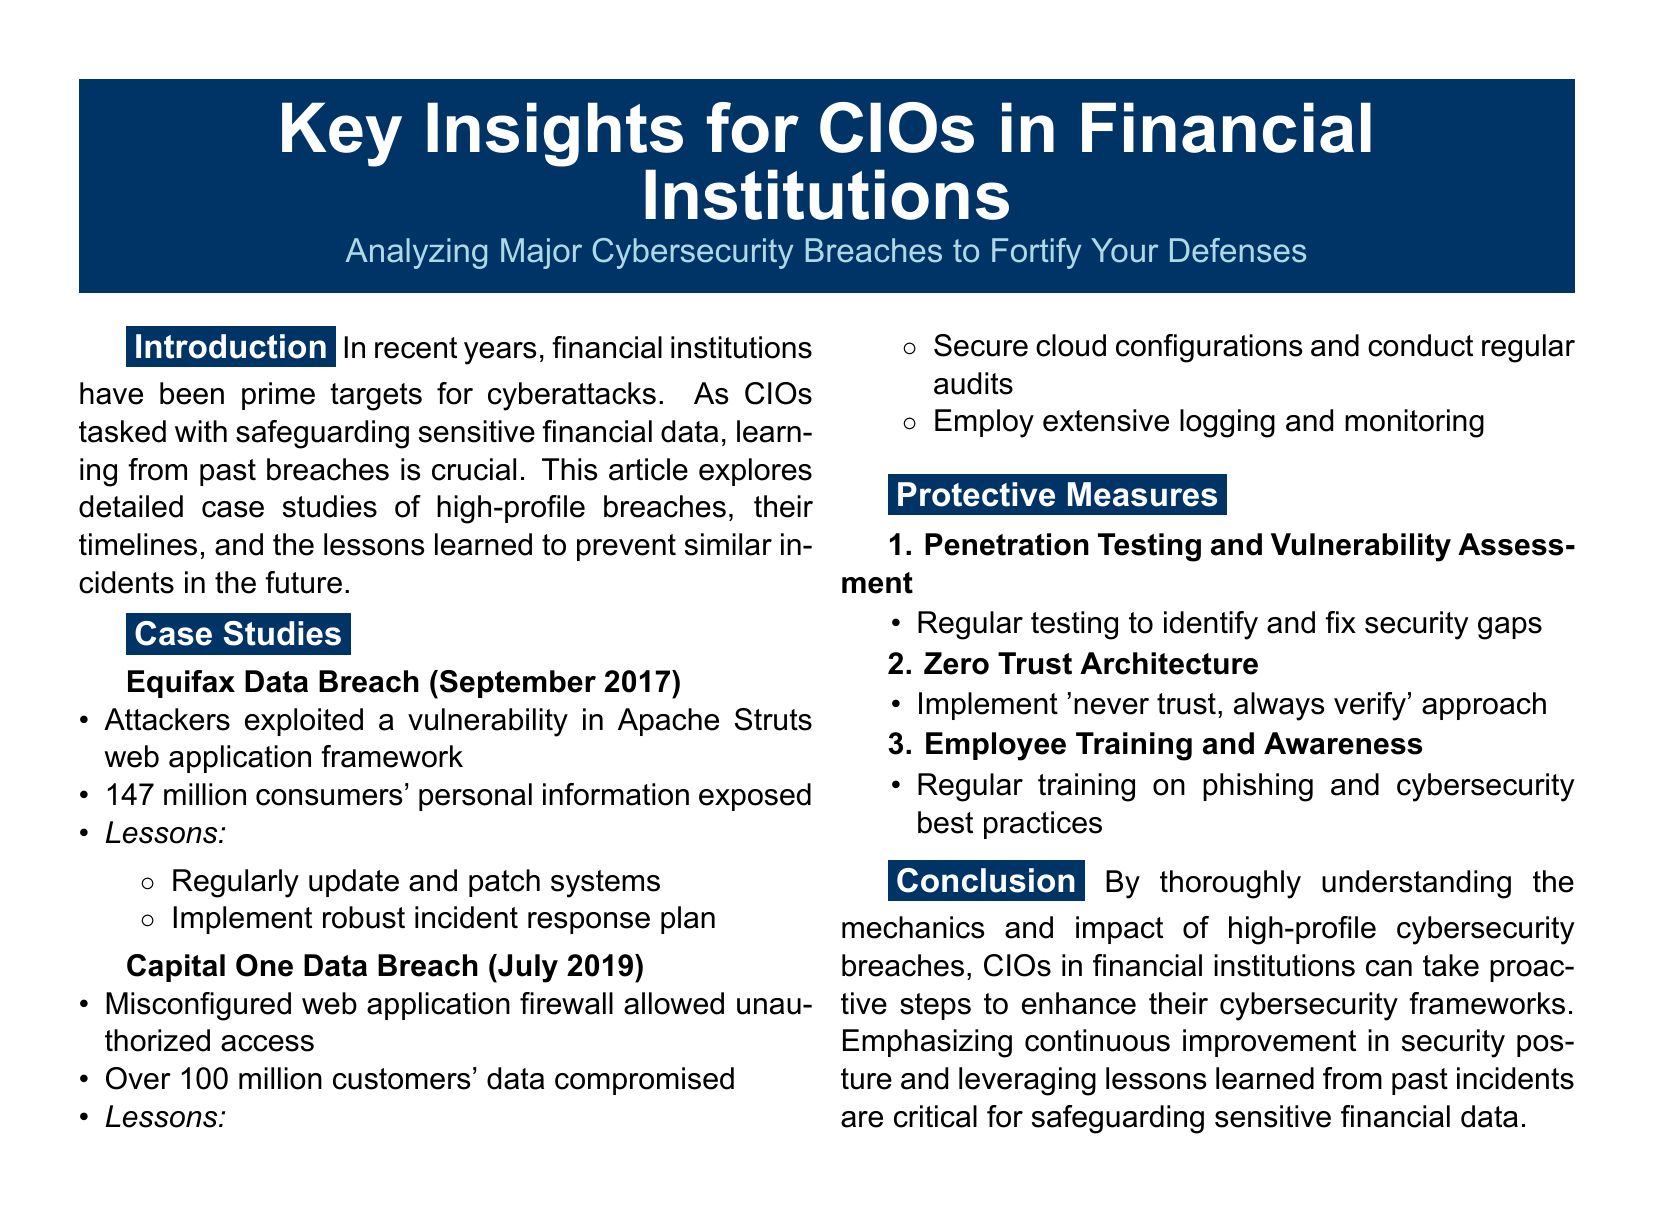What year did the Equifax Data Breach occur? The document states that the Equifax Data Breach occurred in September 2017.
Answer: 2017 How many consumers' personal information was exposed in the Equifax breach? According to the document, 147 million consumers' personal information was exposed in the Equifax breach.
Answer: 147 million What was the cause of the Capital One Data Breach? The document indicates that a misconfigured web application firewall caused the Capital One Data Breach.
Answer: Misconfigured web application firewall What key protective measure is suggested for identifying security gaps? The document lists penetration testing and vulnerability assessment as a key protective measure.
Answer: Penetration testing and vulnerability assessment What breach involved over 100 million customers' data compromised? The document specifies that the Capital One Data Breach involved over 100 million customers' data compromised.
Answer: Capital One Data Breach What is the approach described as 'never trust, always verify'? The document refers to Zero Trust Architecture as the approach described as 'never trust, always verify'.
Answer: Zero Trust Architecture What was a lesson learned from the Equifax breach? The document lists that regularly updating and patching systems was a lesson learned from the Equifax breach.
Answer: Regularly update and patch systems How frequently should training on phishing be conducted according to the document? The document advises regular training on phishing and cybersecurity best practices.
Answer: Regularly What type of article is this document classified as? The document is classified as an article providing insights for CIOs in financial institutions.
Answer: Article 